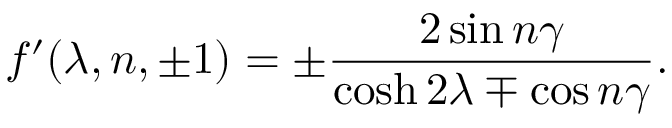<formula> <loc_0><loc_0><loc_500><loc_500>f ^ { \prime } ( \lambda , n , \pm 1 ) = \pm \frac { 2 \sin n \gamma } { \cosh 2 \lambda \mp \cos n \gamma } .</formula> 